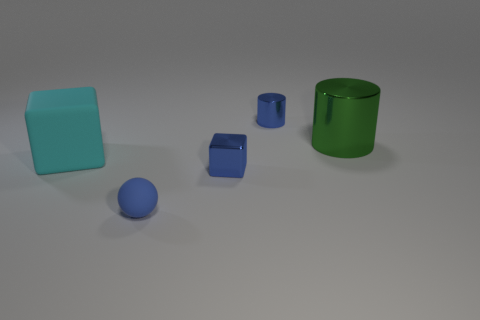Add 5 large rubber blocks. How many objects exist? 10 Subtract all blue blocks. How many blocks are left? 1 Subtract all blue matte objects. Subtract all cyan objects. How many objects are left? 3 Add 4 large green metal objects. How many large green metal objects are left? 5 Add 3 green shiny things. How many green shiny things exist? 4 Subtract 0 purple cylinders. How many objects are left? 5 Subtract all cylinders. How many objects are left? 3 Subtract 1 spheres. How many spheres are left? 0 Subtract all purple spheres. Subtract all brown cylinders. How many spheres are left? 1 Subtract all brown blocks. How many blue cylinders are left? 1 